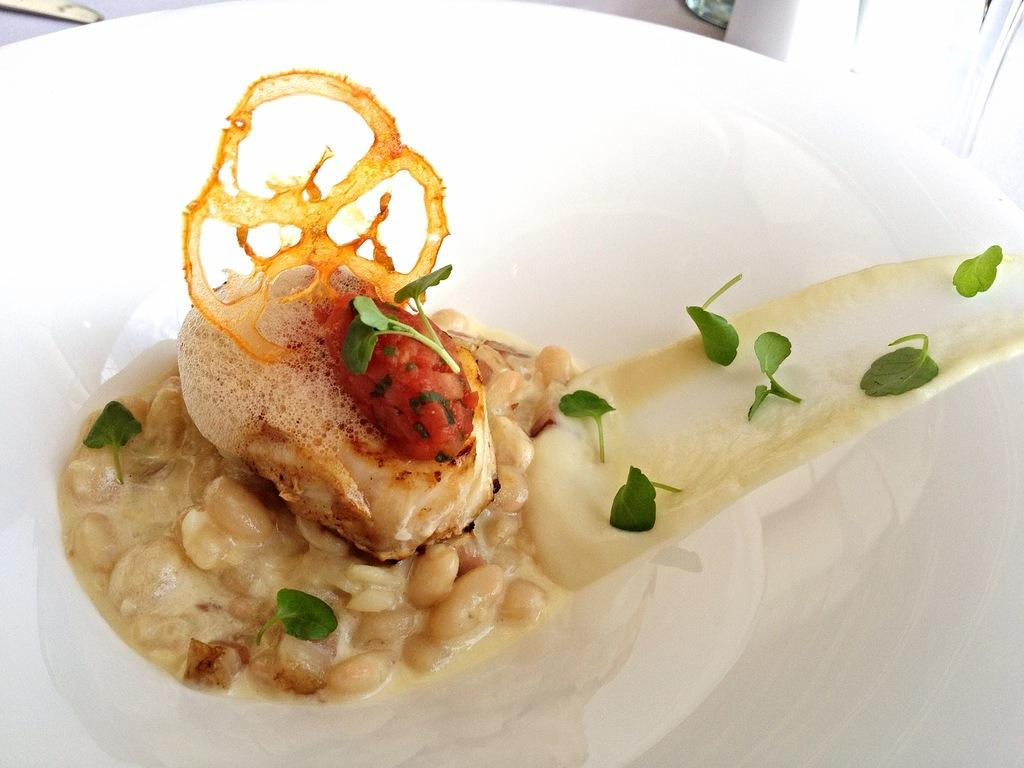What type of food is featured in the image? There is a dessert in the image. What ingredients can be found in the dessert? The dessert contains nuts, mint leaves, and crispy balls. What is the dessert served in? The dessert is in a white bowl. What type of stone is used as a topping for the dessert in the image? There is no stone used as a topping for the dessert in the image. How does the journey of the dessert affect its taste? The image does not provide any information about the dessert's journey, so it is impossible to determine how it might affect its taste. 